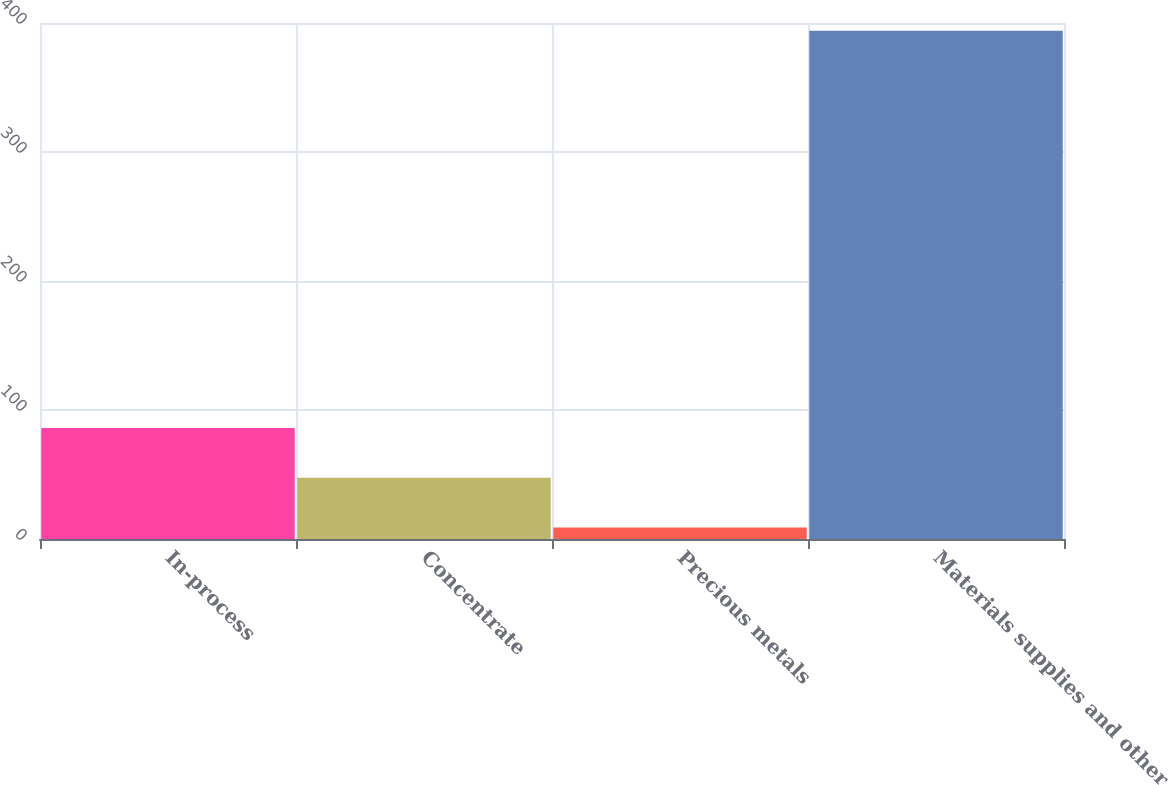Convert chart to OTSL. <chart><loc_0><loc_0><loc_500><loc_500><bar_chart><fcel>In-process<fcel>Concentrate<fcel>Precious metals<fcel>Materials supplies and other<nl><fcel>86<fcel>47.5<fcel>9<fcel>394<nl></chart> 